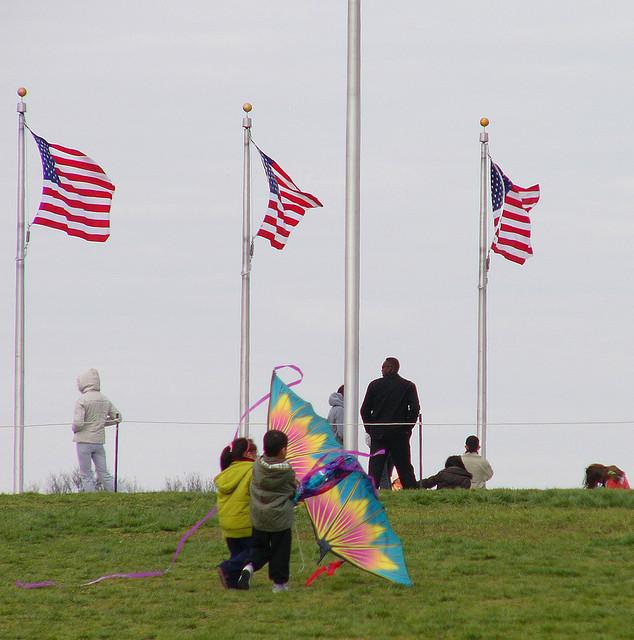How many flagpoles are visible?
Quick response, please. 4. What color are the flags?
Quick response, please. Red white and blue. Is this picture taken in America?
Answer briefly. Yes. 